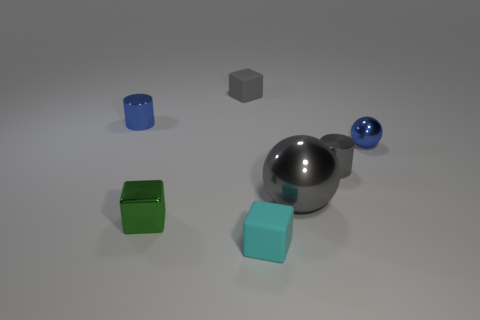What shape is the small shiny object that is the same color as the large shiny sphere?
Your answer should be very brief. Cylinder. There is a small cyan matte cube; what number of big gray things are in front of it?
Offer a very short reply. 0. What material is the tiny object that is behind the blue thing behind the small shiny ball?
Your response must be concise. Rubber. Is there a tiny rubber block that has the same color as the large thing?
Offer a very short reply. Yes. There is a gray sphere that is made of the same material as the tiny green object; what size is it?
Provide a succinct answer. Large. Is there any other thing that is the same color as the big metallic ball?
Keep it short and to the point. Yes. What is the color of the cylinder that is on the left side of the small cyan matte block?
Give a very brief answer. Blue. There is a blue shiny object that is right of the small metal cylinder on the left side of the cyan matte object; is there a tiny cyan cube to the right of it?
Offer a very short reply. No. Are there more small rubber blocks left of the gray cube than tiny green metallic cylinders?
Offer a very short reply. No. Do the green object on the left side of the tiny metallic sphere and the big gray thing have the same shape?
Provide a short and direct response. No. 